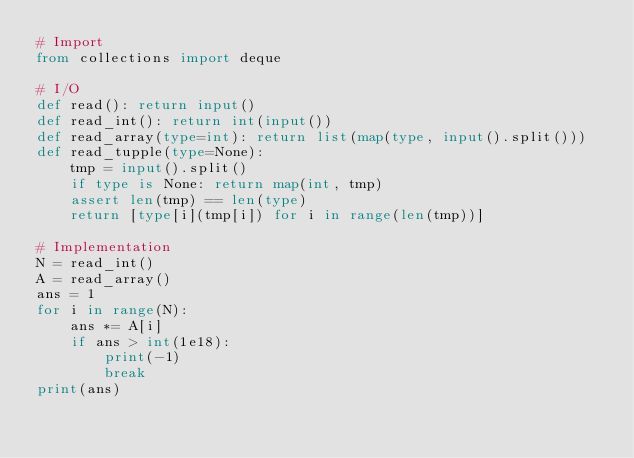Convert code to text. <code><loc_0><loc_0><loc_500><loc_500><_Python_># Import
from collections import deque

# I/O
def read(): return input()
def read_int(): return int(input())
def read_array(type=int): return list(map(type, input().split()))
def read_tupple(type=None):
    tmp = input().split()
    if type is None: return map(int, tmp)
    assert len(tmp) == len(type)
    return [type[i](tmp[i]) for i in range(len(tmp))]

# Implementation
N = read_int()
A = read_array()
ans = 1
for i in range(N):
    ans *= A[i]
    if ans > int(1e18):
        print(-1)
        break
print(ans)</code> 